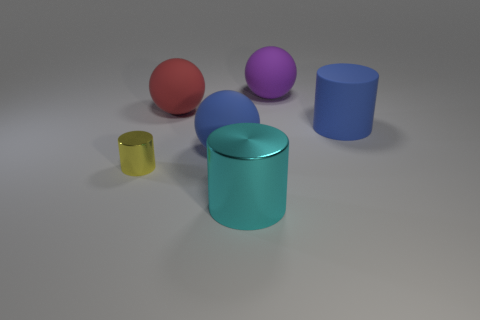What is the shape of the red rubber object?
Offer a terse response. Sphere. There is a cylinder that is the same material as the blue sphere; what is its color?
Ensure brevity in your answer.  Blue. Are there more red rubber things than balls?
Provide a short and direct response. No. Is there a small yellow metallic object?
Keep it short and to the point. Yes. There is a shiny thing in front of the object that is left of the red rubber ball; what is its shape?
Give a very brief answer. Cylinder. What number of objects are either cyan metal cubes or objects in front of the yellow object?
Provide a succinct answer. 1. What is the color of the thing that is right of the big purple rubber ball on the left side of the large blue thing that is right of the purple matte thing?
Your answer should be very brief. Blue. What material is the blue thing that is the same shape as the cyan object?
Your response must be concise. Rubber. What color is the small cylinder?
Ensure brevity in your answer.  Yellow. Does the tiny shiny object have the same color as the large metal cylinder?
Provide a short and direct response. No. 